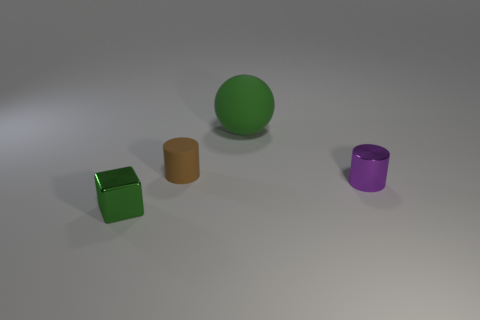Add 4 small shiny objects. How many objects exist? 8 Subtract all balls. How many objects are left? 3 Subtract 0 red cubes. How many objects are left? 4 Subtract all small blue spheres. Subtract all small purple cylinders. How many objects are left? 3 Add 4 small metallic cubes. How many small metallic cubes are left? 5 Add 1 metal cubes. How many metal cubes exist? 2 